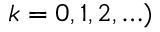<formula> <loc_0><loc_0><loc_500><loc_500>k = 0 , 1 , 2 , \dots )</formula> 